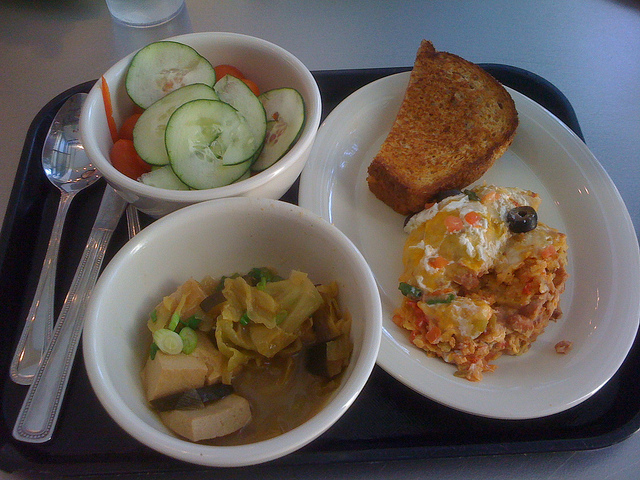<image>What meal is this fruit most associated with? I don't know what meal this fruit is most associated with. It could be associated with breakfast or lunch. What meal is this fruit most associated with? I don't know what meal this fruit is most associated with. It can be seen in salads, lunch or breakfast. 